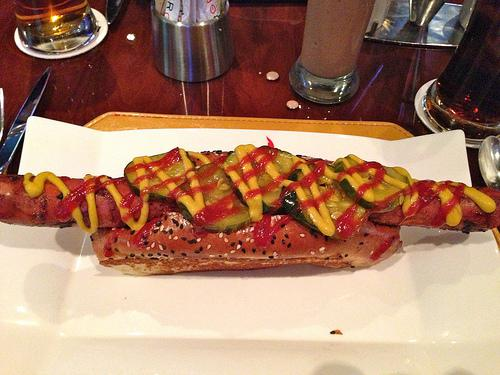Question: what is the meat on this bun?
Choices:
A. Hamburger.
B. Hot dog.
C. Sausage.
D. Pulled pork.
Answer with the letter. Answer: B Question: how many pickles are on this hotdog?
Choices:
A. Three.
B. Two.
C. Four.
D. Five.
Answer with the letter. Answer: D Question: where was this photo taken?
Choices:
A. At a park.
B. At a bar.
C. At the bus stop.
D. At a restaurant.
Answer with the letter. Answer: D 